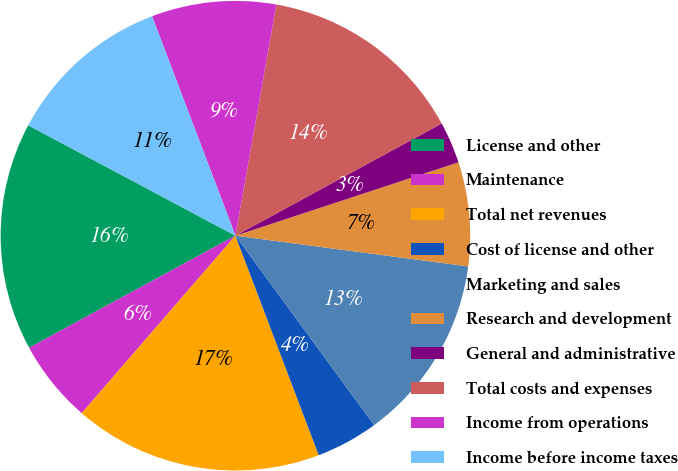Convert chart. <chart><loc_0><loc_0><loc_500><loc_500><pie_chart><fcel>License and other<fcel>Maintenance<fcel>Total net revenues<fcel>Cost of license and other<fcel>Marketing and sales<fcel>Research and development<fcel>General and administrative<fcel>Total costs and expenses<fcel>Income from operations<fcel>Income before income taxes<nl><fcel>15.71%<fcel>5.72%<fcel>17.13%<fcel>4.29%<fcel>12.85%<fcel>7.15%<fcel>2.87%<fcel>14.28%<fcel>8.57%<fcel>11.43%<nl></chart> 